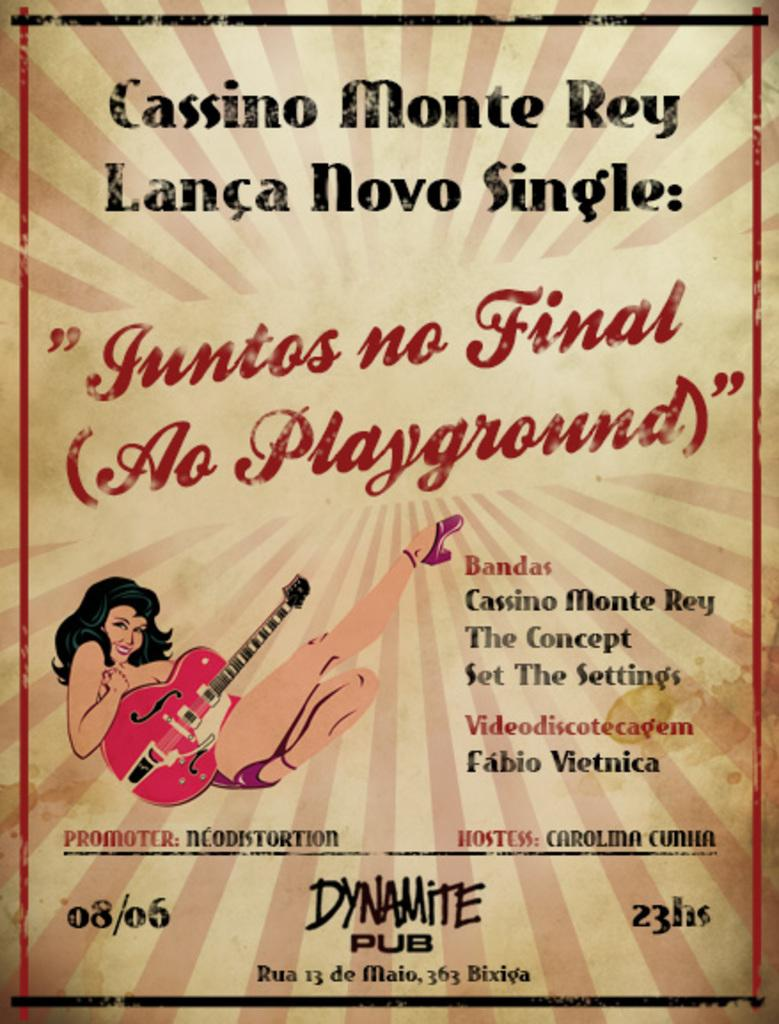What is featured in the image? There is a poster in the image. What can be found on the poster? There is text on the poster and a cartoon image of a woman. What is the woman holding in the cartoon image? The woman is holding a guitar in the cartoon image. What type of square can be seen in the image? There is no square present in the image. Is there any motion or action taking place in the image? The image is static, and there is no motion or action depicted. 